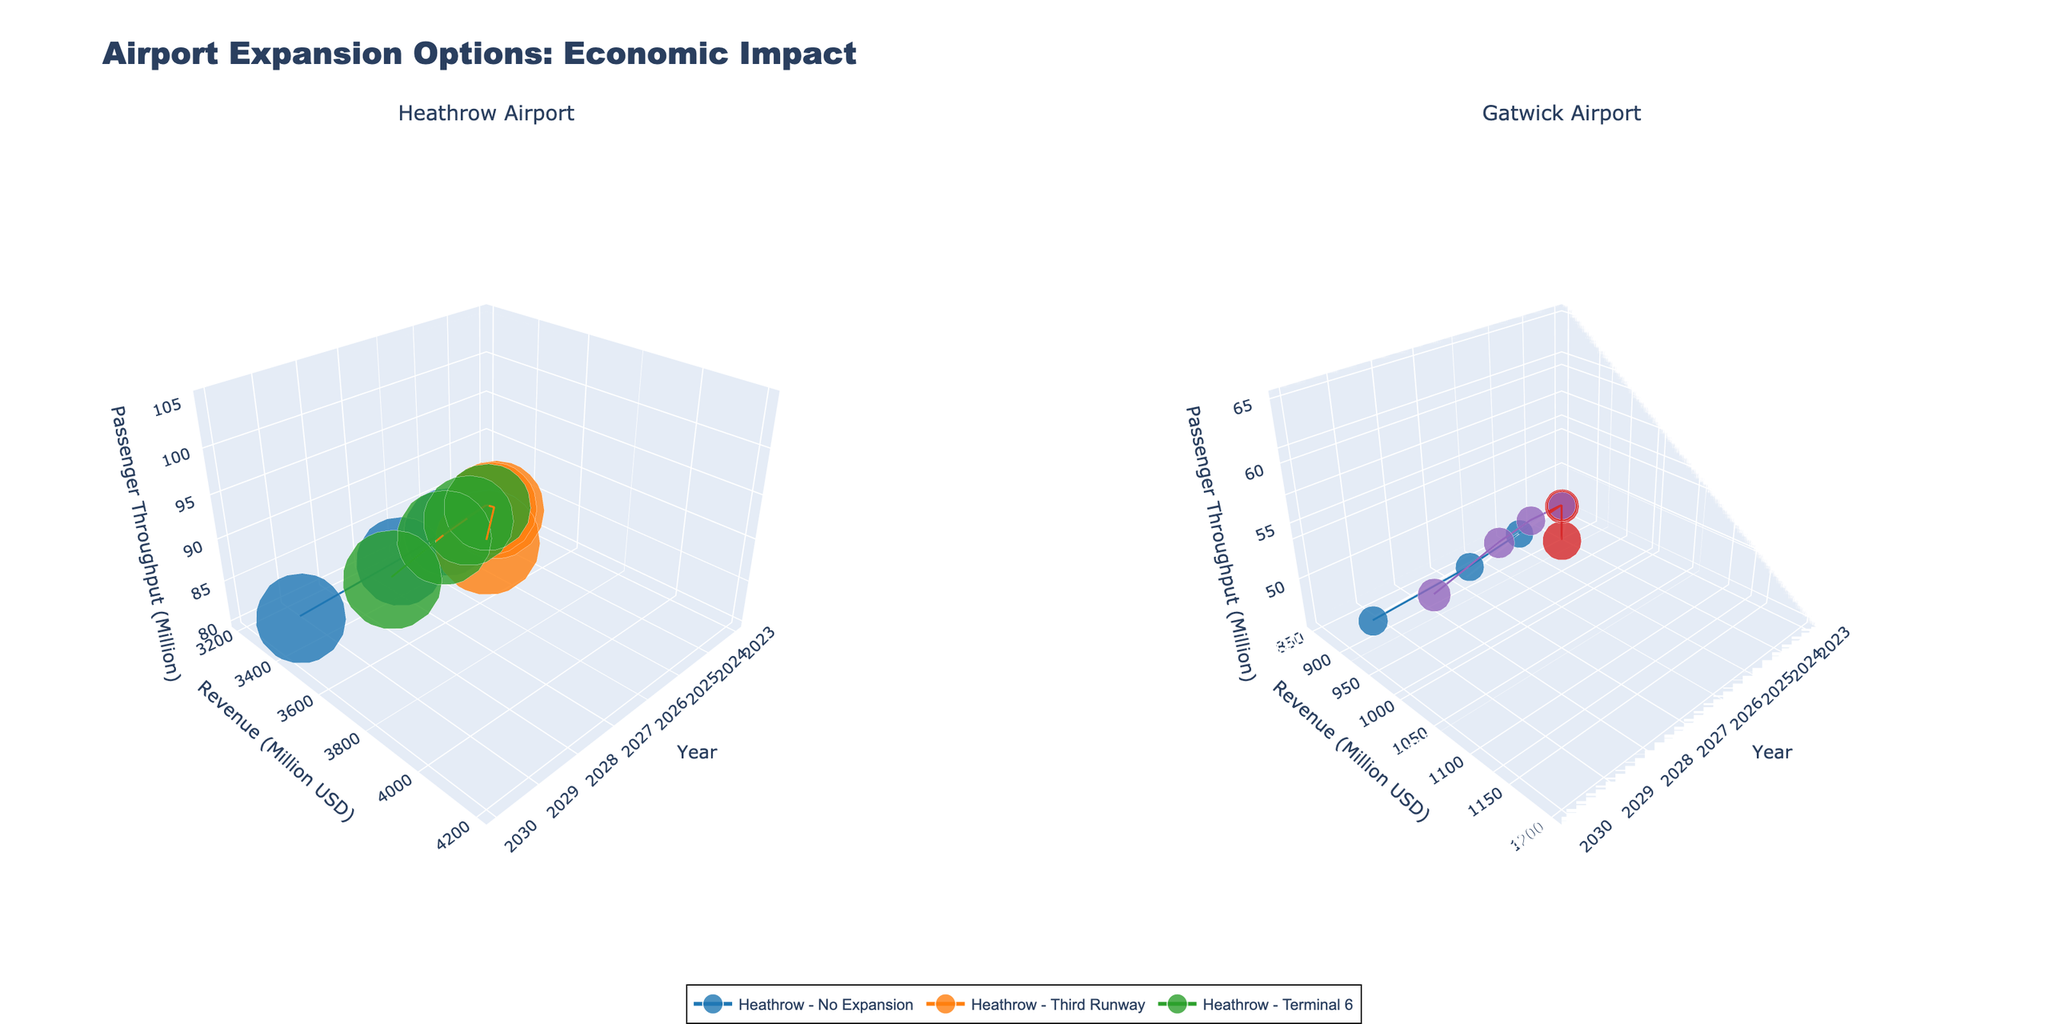How many expansion options are shown for Heathrow Airport? There are three expansion options shown in the plot for Heathrow Airport: No Expansion, Third Runway, and Terminal 6. This can be identified by looking at the legend and the data points on the left subplot.
Answer: 3 What is the trend in revenue for Heathrow Airport with the Third Runway option from 2025 to 2030? To determine the trend, look at the data points connected by the line for the Third Runway option in the left subplot. From 2025 to 2030, the revenue increases from 3500 million USD to 4200 million USD. This indicates an upward trend.
Answer: Upward Which expansion option creates the most jobs for Gatwick Airport by 2030? By examining the size of the markers (which represents jobs created) for 2030 in the right subplot, the Second Runway option has the largest marker. This indicates it creates the most jobs.
Answer: Second Runway Between Heathrow and Gatwick airports, which one experiences the highest revenue with any expansion by 2030? To compare, look at the peak values of revenue for any expansion option in 2030 in both subplots. Heathrow Airport, with the Third Runway option, has the highest revenue of 4200 million USD.
Answer: Heathrow What is the difference in passenger throughput between Gatwick's No Expansion and Second Runway options in 2027? From the plotted data points in the right subplot, Gatwick's No Expansion option in 2027 has a throughput of 48 million passengers, while the Second Runway has 58 million passengers. The difference is 58 - 48 = 10 million passengers.
Answer: 10 million How does the job creation for Heathrow's Terminal 6 in 2025 compare to that in 2027? Check the size of the markers for Heathrow's Terminal 6 option in the left subplot for 2025 and 2027. The jobs created are 79,000 in 2025 and 83,000 in 2027. Calculating the difference: 83,000 - 79,000 = 4,000 more jobs in 2027.
Answer: 4,000 more jobs What are the axis titles in the figure? The figure has three common axis titles for the 3D plots on both subplots. The x-axis is "Year," the y-axis is "Revenue (Million USD)," and the z-axis is "Passenger Throughput (Million)." This can be observed from the axis labels.
Answer: Year, Revenue (Million USD), Passenger Throughput (Million) Which expansion option for Heathrow Airport shows the highest increase in revenue from 2025 to 2027? Check the revenue increase for each expansion option between 2025 and 2027 in the left subplot. The Third Runway option increases from 3500 million USD to 3800 million USD, showing the highest increase.
Answer: Third Runway In 2030, which expansion option results in higher passenger throughput for both airports? Compare the passenger throughput values in 2030 for each expansion option in both subplots. Heathrow's Third Runway option has 105 million passengers, and Gatwick's Second Runway has 65 million passengers. Thus, Heathrow's Third Runway has higher passenger throughput.
Answer: Heathrow’s Third Runway What is the revenue difference between Gatwick's North Terminal Extension option in 2023 and 2030? Identify the revenue data points for Gatwick's North Terminal Extension option in 2023 and 2030 in the right subplot. The revenue is 850 million USD in 2023 and 1050 million USD in 2030. The difference is 1050 - 850 = 200 million USD.
Answer: 200 million USD 